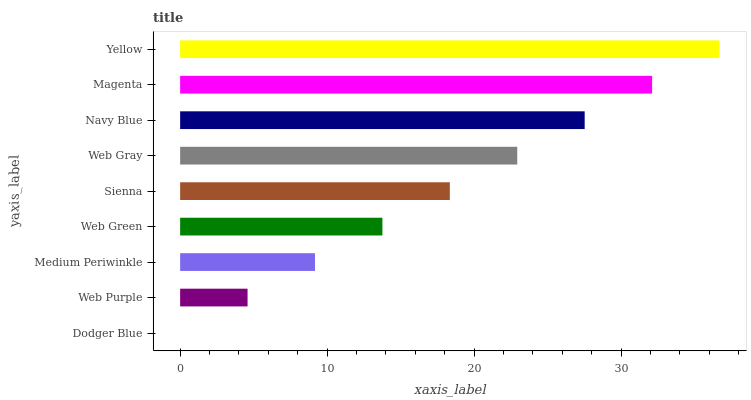Is Dodger Blue the minimum?
Answer yes or no. Yes. Is Yellow the maximum?
Answer yes or no. Yes. Is Web Purple the minimum?
Answer yes or no. No. Is Web Purple the maximum?
Answer yes or no. No. Is Web Purple greater than Dodger Blue?
Answer yes or no. Yes. Is Dodger Blue less than Web Purple?
Answer yes or no. Yes. Is Dodger Blue greater than Web Purple?
Answer yes or no. No. Is Web Purple less than Dodger Blue?
Answer yes or no. No. Is Sienna the high median?
Answer yes or no. Yes. Is Sienna the low median?
Answer yes or no. Yes. Is Web Purple the high median?
Answer yes or no. No. Is Navy Blue the low median?
Answer yes or no. No. 